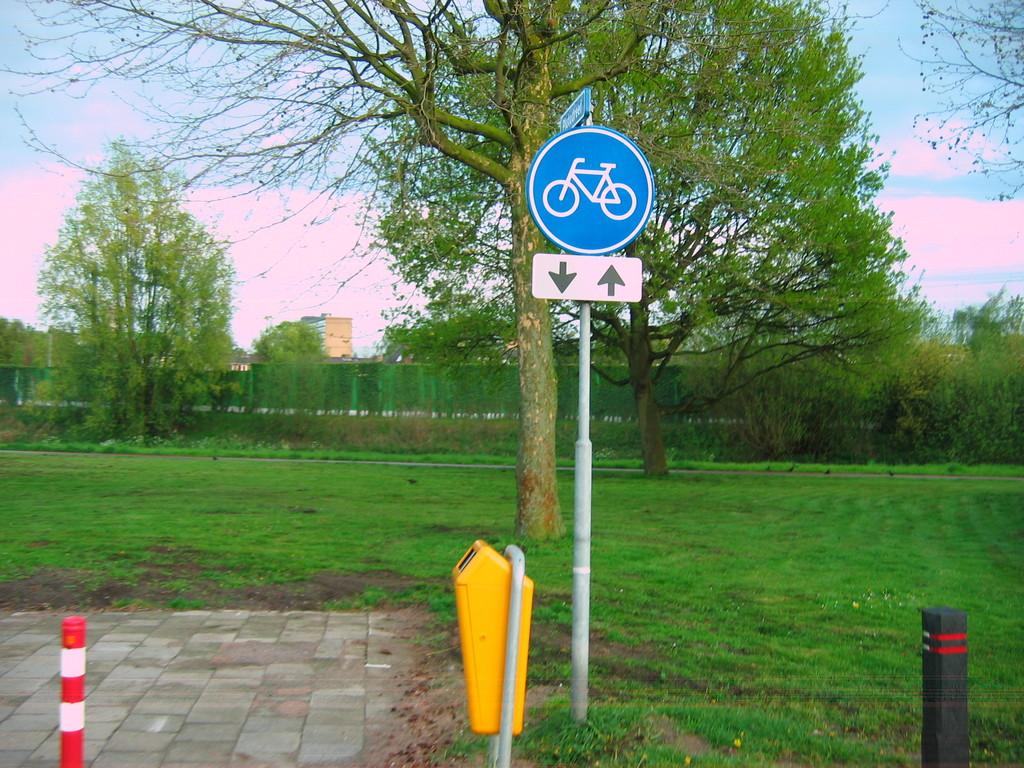What type of surface covers the ground in the image? The ground in the image is covered with grass. What object can be seen providing information or direction in the image? There is a sign board in the image. What type of container is present on the ground in the image? There is a small dustbin on the ground in the image. What type of material is the suit made of in the image? There is no suit present in the image. How many pizzas are visible on the ground in the image? There are no pizzas present in the image. 